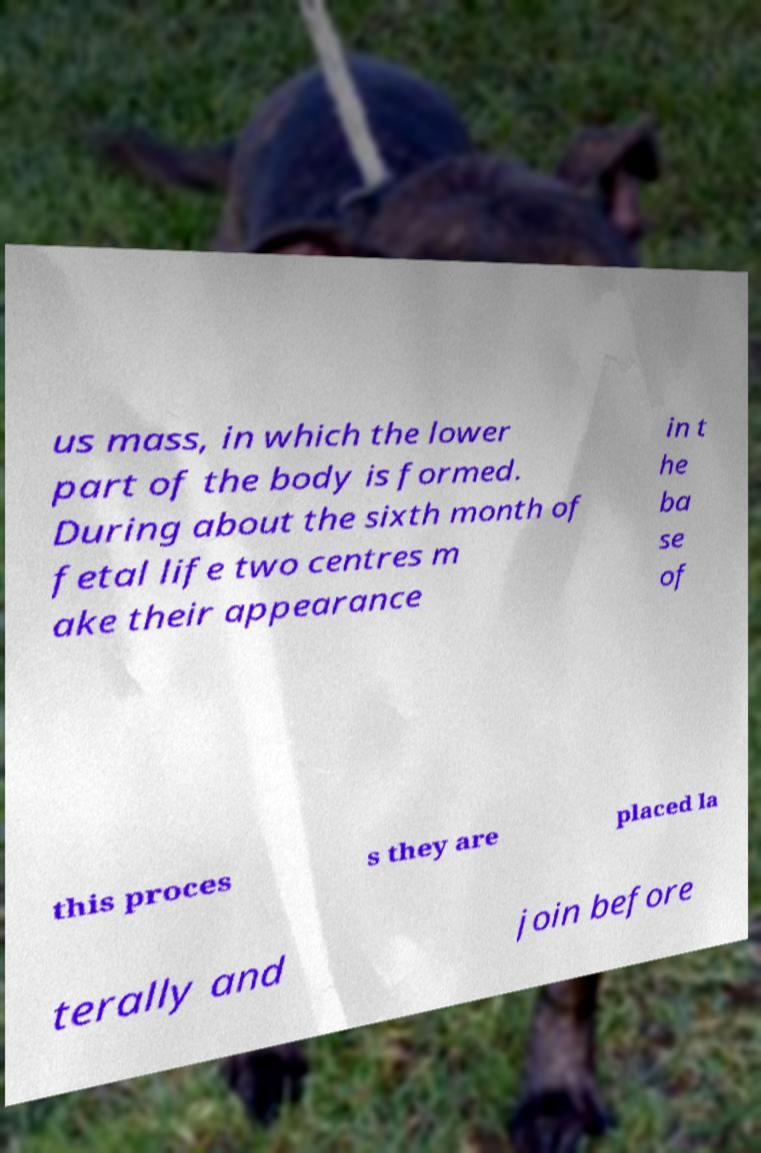For documentation purposes, I need the text within this image transcribed. Could you provide that? us mass, in which the lower part of the body is formed. During about the sixth month of fetal life two centres m ake their appearance in t he ba se of this proces s they are placed la terally and join before 